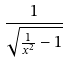Convert formula to latex. <formula><loc_0><loc_0><loc_500><loc_500>\frac { 1 } { \sqrt { \frac { 1 } { x ^ { 2 } } - 1 } }</formula> 